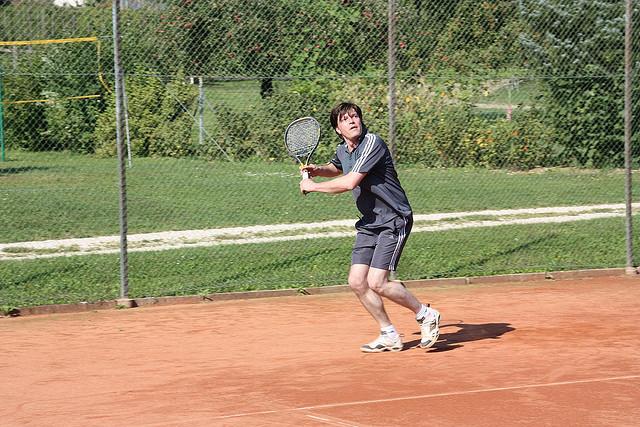Is the man wearing shoes?
Quick response, please. Yes. What sport is this child playing?
Keep it brief. Tennis. What does he have in his hands?
Answer briefly. Racquet. What type of surface is the tennis match being played on?
Concise answer only. Clay. What sport is the man playing?
Be succinct. Tennis. 